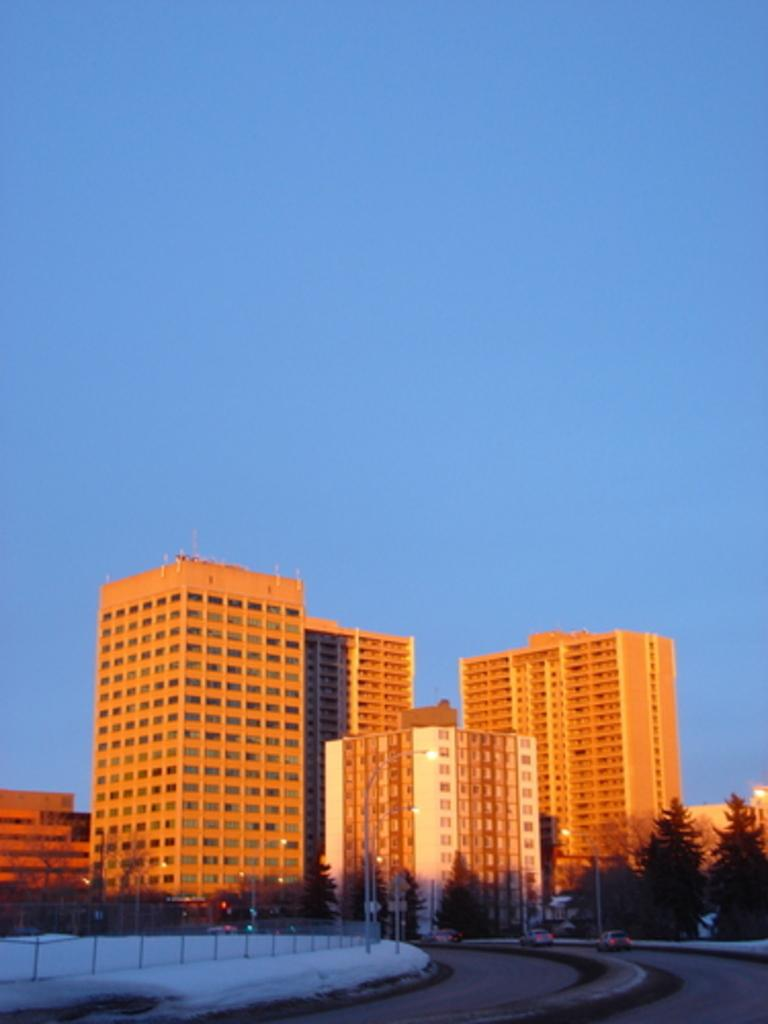What type of structures can be seen in the image? There are buildings in the image. What kind of vegetation is present in the image? There are trees with green color in the image. What architectural feature is visible in the image? There is a railing in the image. What is the color of the sky in the image? The sky is blue in the image. What type of skin condition is visible on the trees in the image? There is no mention of any skin condition on the trees in the image; they are described as having green color. What agreement was made between the buildings in the image? There is no indication of any agreement between the buildings in the image; they are simply structures. 